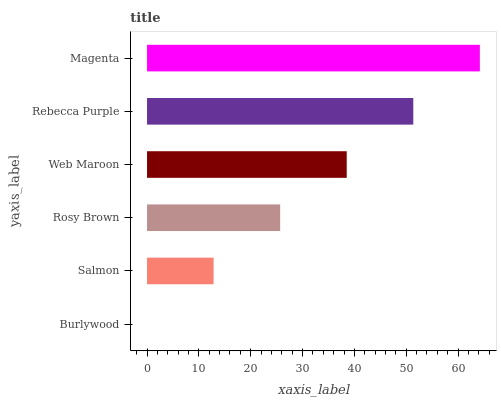Is Burlywood the minimum?
Answer yes or no. Yes. Is Magenta the maximum?
Answer yes or no. Yes. Is Salmon the minimum?
Answer yes or no. No. Is Salmon the maximum?
Answer yes or no. No. Is Salmon greater than Burlywood?
Answer yes or no. Yes. Is Burlywood less than Salmon?
Answer yes or no. Yes. Is Burlywood greater than Salmon?
Answer yes or no. No. Is Salmon less than Burlywood?
Answer yes or no. No. Is Web Maroon the high median?
Answer yes or no. Yes. Is Rosy Brown the low median?
Answer yes or no. Yes. Is Magenta the high median?
Answer yes or no. No. Is Web Maroon the low median?
Answer yes or no. No. 